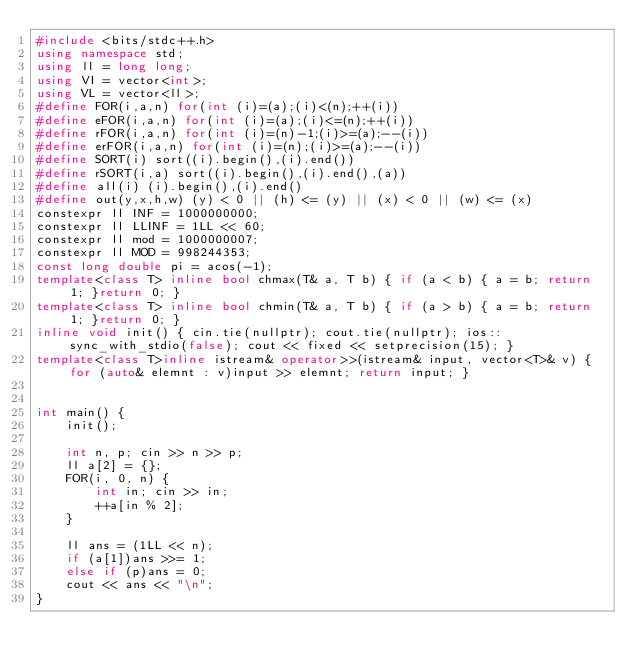<code> <loc_0><loc_0><loc_500><loc_500><_C++_>#include <bits/stdc++.h>
using namespace std;
using ll = long long;
using VI = vector<int>;
using VL = vector<ll>;
#define FOR(i,a,n) for(int (i)=(a);(i)<(n);++(i))
#define eFOR(i,a,n) for(int (i)=(a);(i)<=(n);++(i))
#define rFOR(i,a,n) for(int (i)=(n)-1;(i)>=(a);--(i))
#define erFOR(i,a,n) for(int (i)=(n);(i)>=(a);--(i))
#define SORT(i) sort((i).begin(),(i).end())
#define rSORT(i,a) sort((i).begin(),(i).end(),(a))
#define all(i) (i).begin(),(i).end()
#define out(y,x,h,w) (y) < 0 || (h) <= (y) || (x) < 0 || (w) <= (x)
constexpr ll INF = 1000000000;
constexpr ll LLINF = 1LL << 60;
constexpr ll mod = 1000000007;
constexpr ll MOD = 998244353;
const long double pi = acos(-1);
template<class T> inline bool chmax(T& a, T b) { if (a < b) { a = b; return 1; }return 0; }
template<class T> inline bool chmin(T& a, T b) { if (a > b) { a = b; return 1; }return 0; }
inline void init() { cin.tie(nullptr); cout.tie(nullptr); ios::sync_with_stdio(false); cout << fixed << setprecision(15); }
template<class T>inline istream& operator>>(istream& input, vector<T>& v) { for (auto& elemnt : v)input >> elemnt; return input; }


int main() {
    init();

    int n, p; cin >> n >> p;
    ll a[2] = {};
    FOR(i, 0, n) {
        int in; cin >> in;
        ++a[in % 2];
    }

    ll ans = (1LL << n);
    if (a[1])ans >>= 1;
    else if (p)ans = 0;
    cout << ans << "\n";
}
</code> 